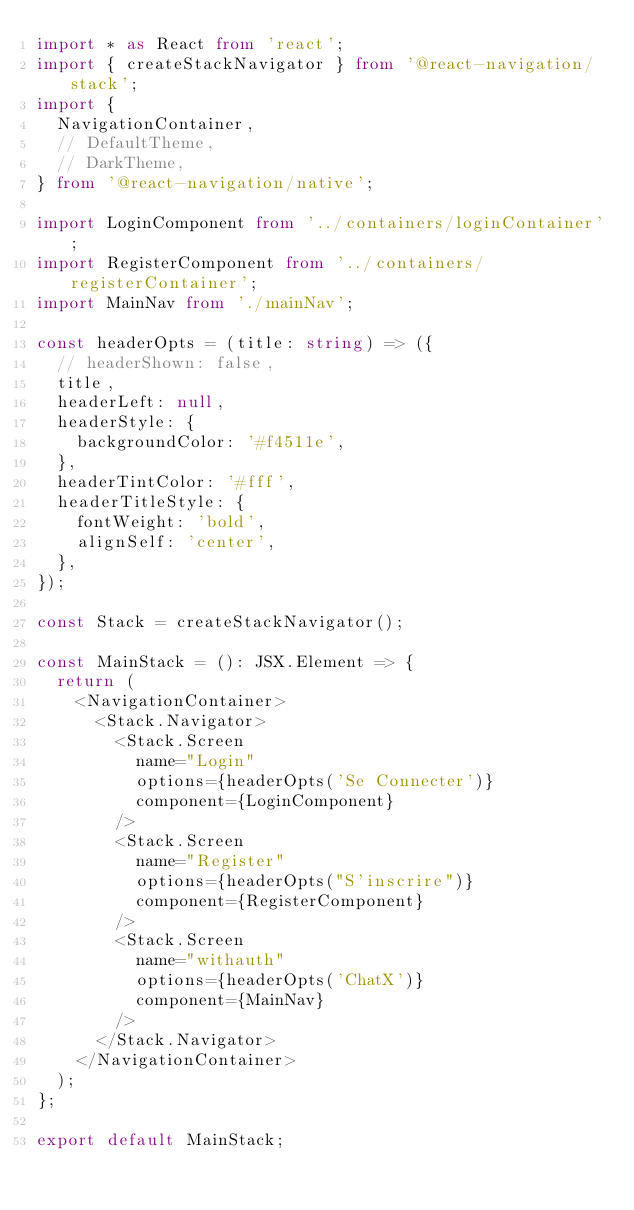<code> <loc_0><loc_0><loc_500><loc_500><_TypeScript_>import * as React from 'react';
import { createStackNavigator } from '@react-navigation/stack';
import {
  NavigationContainer,
  // DefaultTheme,
  // DarkTheme,
} from '@react-navigation/native';

import LoginComponent from '../containers/loginContainer';
import RegisterComponent from '../containers/registerContainer';
import MainNav from './mainNav';

const headerOpts = (title: string) => ({
  // headerShown: false,
  title,
  headerLeft: null,
  headerStyle: {
    backgroundColor: '#f4511e',
  },
  headerTintColor: '#fff',
  headerTitleStyle: {
    fontWeight: 'bold',
    alignSelf: 'center',
  },
});

const Stack = createStackNavigator();

const MainStack = (): JSX.Element => {
  return (
    <NavigationContainer>
      <Stack.Navigator>
        <Stack.Screen
          name="Login"
          options={headerOpts('Se Connecter')}
          component={LoginComponent}
        />
        <Stack.Screen
          name="Register"
          options={headerOpts("S'inscrire")}
          component={RegisterComponent}
        />
        <Stack.Screen
          name="withauth"
          options={headerOpts('ChatX')}
          component={MainNav}
        />
      </Stack.Navigator>
    </NavigationContainer>
  );
};

export default MainStack;
</code> 